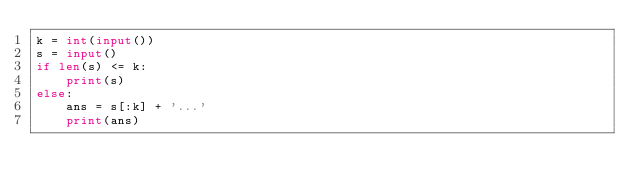Convert code to text. <code><loc_0><loc_0><loc_500><loc_500><_Python_>k = int(input())
s = input()
if len(s) <= k:
    print(s)
else:
    ans = s[:k] + '...'
    print(ans)</code> 